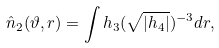<formula> <loc_0><loc_0><loc_500><loc_500>\hat { n } _ { 2 } ( \vartheta , r ) = \int h _ { 3 } ( \sqrt { | h _ { 4 } | } ) ^ { - 3 } d r , \</formula> 